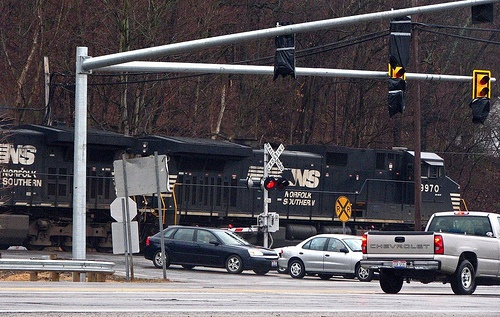Describe the objects in this image and their specific colors. I can see train in black, gray, and darkgray tones, truck in black, darkgray, gray, and lightgray tones, car in black, gray, lightgray, and darkgray tones, car in black, white, darkgray, and gray tones, and traffic light in black, gray, and maroon tones in this image. 